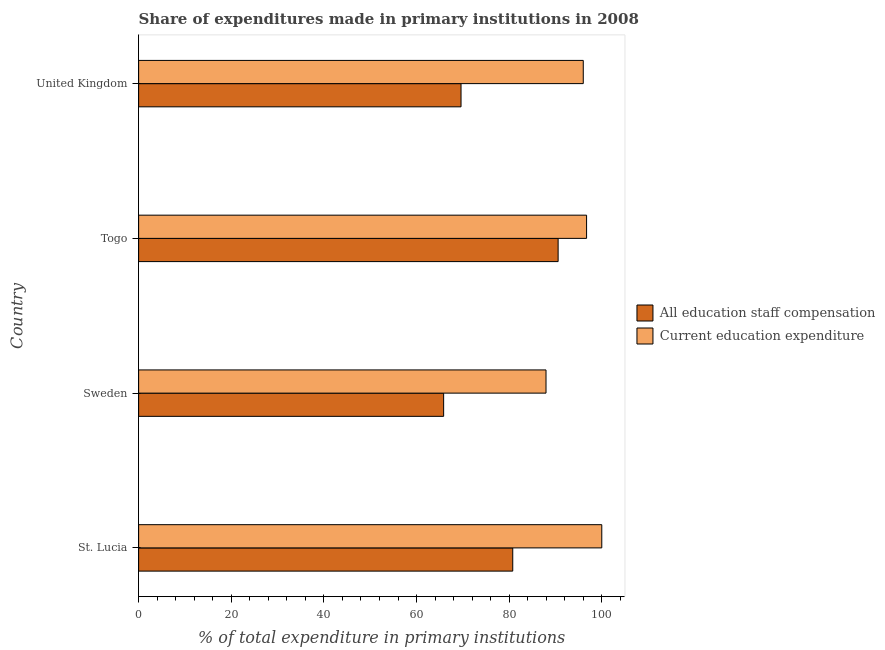How many different coloured bars are there?
Your response must be concise. 2. How many groups of bars are there?
Give a very brief answer. 4. Are the number of bars on each tick of the Y-axis equal?
Ensure brevity in your answer.  Yes. How many bars are there on the 3rd tick from the top?
Provide a succinct answer. 2. How many bars are there on the 2nd tick from the bottom?
Your response must be concise. 2. What is the label of the 4th group of bars from the top?
Offer a terse response. St. Lucia. In how many cases, is the number of bars for a given country not equal to the number of legend labels?
Provide a succinct answer. 0. What is the expenditure in education in Togo?
Ensure brevity in your answer.  96.72. Across all countries, what is the minimum expenditure in staff compensation?
Your response must be concise. 65.85. In which country was the expenditure in education maximum?
Offer a terse response. St. Lucia. What is the total expenditure in education in the graph?
Offer a very short reply. 380.67. What is the difference between the expenditure in education in St. Lucia and that in Sweden?
Your answer should be compact. 12.04. What is the difference between the expenditure in staff compensation in Togo and the expenditure in education in St. Lucia?
Provide a succinct answer. -9.43. What is the average expenditure in education per country?
Provide a succinct answer. 95.17. What is the difference between the expenditure in staff compensation and expenditure in education in Sweden?
Ensure brevity in your answer.  -22.1. In how many countries, is the expenditure in education greater than 72 %?
Make the answer very short. 4. Is the expenditure in education in St. Lucia less than that in Sweden?
Make the answer very short. No. Is the difference between the expenditure in staff compensation in St. Lucia and United Kingdom greater than the difference between the expenditure in education in St. Lucia and United Kingdom?
Provide a succinct answer. Yes. What is the difference between the highest and the second highest expenditure in education?
Offer a terse response. 3.28. What is the difference between the highest and the lowest expenditure in staff compensation?
Provide a succinct answer. 24.72. Is the sum of the expenditure in staff compensation in Sweden and United Kingdom greater than the maximum expenditure in education across all countries?
Offer a terse response. Yes. What does the 1st bar from the top in Sweden represents?
Give a very brief answer. Current education expenditure. What does the 2nd bar from the bottom in United Kingdom represents?
Your response must be concise. Current education expenditure. How many bars are there?
Offer a very short reply. 8. Are all the bars in the graph horizontal?
Ensure brevity in your answer.  Yes. How many countries are there in the graph?
Offer a terse response. 4. Are the values on the major ticks of X-axis written in scientific E-notation?
Give a very brief answer. No. Does the graph contain any zero values?
Make the answer very short. No. Where does the legend appear in the graph?
Your answer should be very brief. Center right. What is the title of the graph?
Offer a terse response. Share of expenditures made in primary institutions in 2008. What is the label or title of the X-axis?
Ensure brevity in your answer.  % of total expenditure in primary institutions. What is the label or title of the Y-axis?
Your answer should be very brief. Country. What is the % of total expenditure in primary institutions of All education staff compensation in St. Lucia?
Give a very brief answer. 80.78. What is the % of total expenditure in primary institutions in Current education expenditure in St. Lucia?
Offer a terse response. 100. What is the % of total expenditure in primary institutions of All education staff compensation in Sweden?
Your answer should be very brief. 65.85. What is the % of total expenditure in primary institutions in Current education expenditure in Sweden?
Make the answer very short. 87.96. What is the % of total expenditure in primary institutions of All education staff compensation in Togo?
Your answer should be compact. 90.57. What is the % of total expenditure in primary institutions in Current education expenditure in Togo?
Offer a very short reply. 96.72. What is the % of total expenditure in primary institutions of All education staff compensation in United Kingdom?
Offer a terse response. 69.61. What is the % of total expenditure in primary institutions in Current education expenditure in United Kingdom?
Your response must be concise. 96. Across all countries, what is the maximum % of total expenditure in primary institutions of All education staff compensation?
Offer a very short reply. 90.57. Across all countries, what is the minimum % of total expenditure in primary institutions in All education staff compensation?
Offer a terse response. 65.85. Across all countries, what is the minimum % of total expenditure in primary institutions of Current education expenditure?
Offer a very short reply. 87.96. What is the total % of total expenditure in primary institutions in All education staff compensation in the graph?
Offer a terse response. 306.81. What is the total % of total expenditure in primary institutions of Current education expenditure in the graph?
Give a very brief answer. 380.67. What is the difference between the % of total expenditure in primary institutions of All education staff compensation in St. Lucia and that in Sweden?
Keep it short and to the point. 14.92. What is the difference between the % of total expenditure in primary institutions in Current education expenditure in St. Lucia and that in Sweden?
Offer a terse response. 12.04. What is the difference between the % of total expenditure in primary institutions in All education staff compensation in St. Lucia and that in Togo?
Provide a short and direct response. -9.8. What is the difference between the % of total expenditure in primary institutions of Current education expenditure in St. Lucia and that in Togo?
Give a very brief answer. 3.28. What is the difference between the % of total expenditure in primary institutions in All education staff compensation in St. Lucia and that in United Kingdom?
Give a very brief answer. 11.17. What is the difference between the % of total expenditure in primary institutions of Current education expenditure in St. Lucia and that in United Kingdom?
Ensure brevity in your answer.  4. What is the difference between the % of total expenditure in primary institutions in All education staff compensation in Sweden and that in Togo?
Offer a terse response. -24.72. What is the difference between the % of total expenditure in primary institutions in Current education expenditure in Sweden and that in Togo?
Offer a terse response. -8.76. What is the difference between the % of total expenditure in primary institutions of All education staff compensation in Sweden and that in United Kingdom?
Give a very brief answer. -3.76. What is the difference between the % of total expenditure in primary institutions of Current education expenditure in Sweden and that in United Kingdom?
Your response must be concise. -8.04. What is the difference between the % of total expenditure in primary institutions of All education staff compensation in Togo and that in United Kingdom?
Offer a very short reply. 20.96. What is the difference between the % of total expenditure in primary institutions of Current education expenditure in Togo and that in United Kingdom?
Offer a terse response. 0.72. What is the difference between the % of total expenditure in primary institutions in All education staff compensation in St. Lucia and the % of total expenditure in primary institutions in Current education expenditure in Sweden?
Give a very brief answer. -7.18. What is the difference between the % of total expenditure in primary institutions in All education staff compensation in St. Lucia and the % of total expenditure in primary institutions in Current education expenditure in Togo?
Ensure brevity in your answer.  -15.94. What is the difference between the % of total expenditure in primary institutions in All education staff compensation in St. Lucia and the % of total expenditure in primary institutions in Current education expenditure in United Kingdom?
Offer a terse response. -15.22. What is the difference between the % of total expenditure in primary institutions of All education staff compensation in Sweden and the % of total expenditure in primary institutions of Current education expenditure in Togo?
Your answer should be compact. -30.86. What is the difference between the % of total expenditure in primary institutions of All education staff compensation in Sweden and the % of total expenditure in primary institutions of Current education expenditure in United Kingdom?
Your answer should be compact. -30.15. What is the difference between the % of total expenditure in primary institutions in All education staff compensation in Togo and the % of total expenditure in primary institutions in Current education expenditure in United Kingdom?
Make the answer very short. -5.43. What is the average % of total expenditure in primary institutions of All education staff compensation per country?
Provide a succinct answer. 76.7. What is the average % of total expenditure in primary institutions in Current education expenditure per country?
Your answer should be very brief. 95.17. What is the difference between the % of total expenditure in primary institutions in All education staff compensation and % of total expenditure in primary institutions in Current education expenditure in St. Lucia?
Provide a short and direct response. -19.22. What is the difference between the % of total expenditure in primary institutions in All education staff compensation and % of total expenditure in primary institutions in Current education expenditure in Sweden?
Provide a short and direct response. -22.1. What is the difference between the % of total expenditure in primary institutions of All education staff compensation and % of total expenditure in primary institutions of Current education expenditure in Togo?
Make the answer very short. -6.14. What is the difference between the % of total expenditure in primary institutions of All education staff compensation and % of total expenditure in primary institutions of Current education expenditure in United Kingdom?
Your response must be concise. -26.39. What is the ratio of the % of total expenditure in primary institutions in All education staff compensation in St. Lucia to that in Sweden?
Give a very brief answer. 1.23. What is the ratio of the % of total expenditure in primary institutions in Current education expenditure in St. Lucia to that in Sweden?
Offer a terse response. 1.14. What is the ratio of the % of total expenditure in primary institutions of All education staff compensation in St. Lucia to that in Togo?
Your answer should be compact. 0.89. What is the ratio of the % of total expenditure in primary institutions of Current education expenditure in St. Lucia to that in Togo?
Your answer should be compact. 1.03. What is the ratio of the % of total expenditure in primary institutions in All education staff compensation in St. Lucia to that in United Kingdom?
Offer a terse response. 1.16. What is the ratio of the % of total expenditure in primary institutions of Current education expenditure in St. Lucia to that in United Kingdom?
Offer a very short reply. 1.04. What is the ratio of the % of total expenditure in primary institutions in All education staff compensation in Sweden to that in Togo?
Provide a succinct answer. 0.73. What is the ratio of the % of total expenditure in primary institutions of Current education expenditure in Sweden to that in Togo?
Offer a very short reply. 0.91. What is the ratio of the % of total expenditure in primary institutions in All education staff compensation in Sweden to that in United Kingdom?
Provide a short and direct response. 0.95. What is the ratio of the % of total expenditure in primary institutions of Current education expenditure in Sweden to that in United Kingdom?
Offer a very short reply. 0.92. What is the ratio of the % of total expenditure in primary institutions in All education staff compensation in Togo to that in United Kingdom?
Your response must be concise. 1.3. What is the ratio of the % of total expenditure in primary institutions of Current education expenditure in Togo to that in United Kingdom?
Ensure brevity in your answer.  1.01. What is the difference between the highest and the second highest % of total expenditure in primary institutions in All education staff compensation?
Keep it short and to the point. 9.8. What is the difference between the highest and the second highest % of total expenditure in primary institutions of Current education expenditure?
Your answer should be compact. 3.28. What is the difference between the highest and the lowest % of total expenditure in primary institutions in All education staff compensation?
Keep it short and to the point. 24.72. What is the difference between the highest and the lowest % of total expenditure in primary institutions of Current education expenditure?
Your answer should be compact. 12.04. 